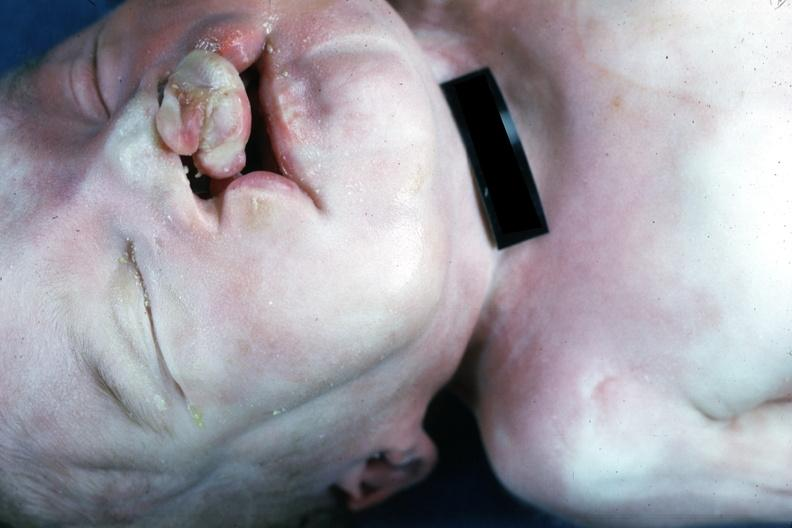what does this image show?
Answer the question using a single word or phrase. External view bilateral cleft palate 